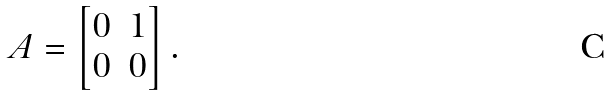Convert formula to latex. <formula><loc_0><loc_0><loc_500><loc_500>A = \begin{bmatrix} 0 & 1 \\ 0 & 0 \end{bmatrix} .</formula> 